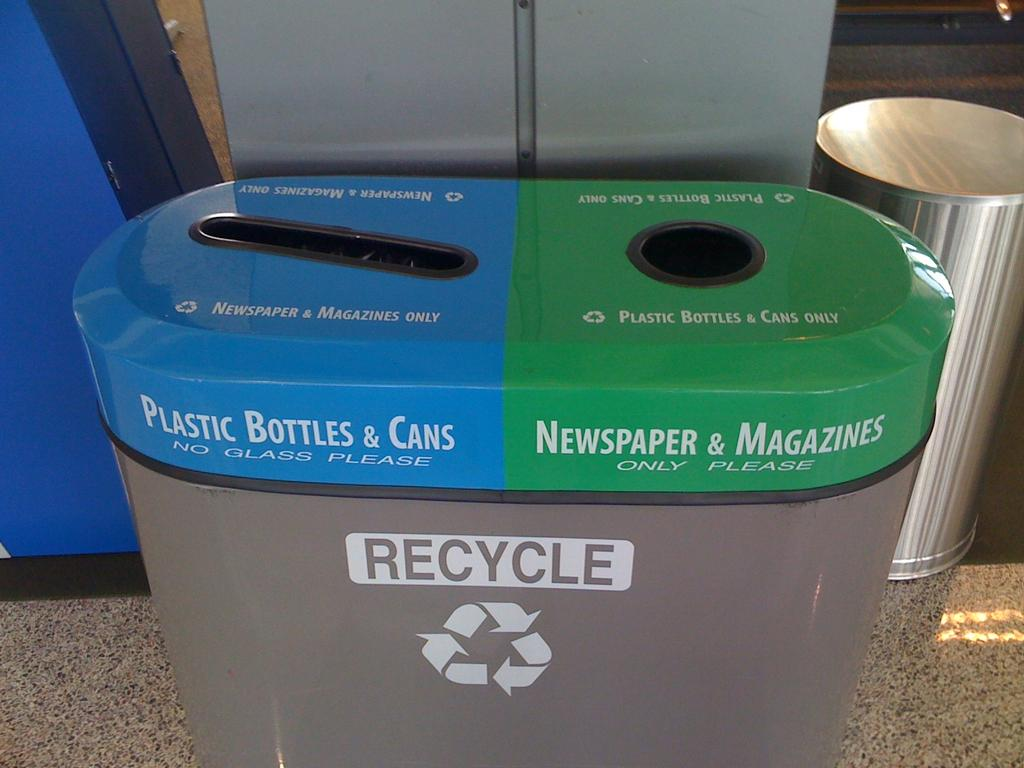<image>
Write a terse but informative summary of the picture. A recycle bin has a note on the bottle and can side that says "no glass please". 